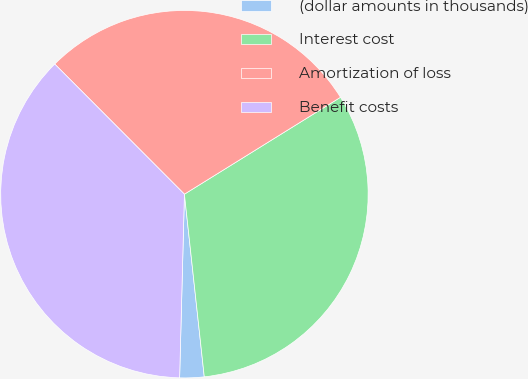<chart> <loc_0><loc_0><loc_500><loc_500><pie_chart><fcel>(dollar amounts in thousands)<fcel>Interest cost<fcel>Amortization of loss<fcel>Benefit costs<nl><fcel>2.14%<fcel>32.12%<fcel>28.63%<fcel>37.11%<nl></chart> 